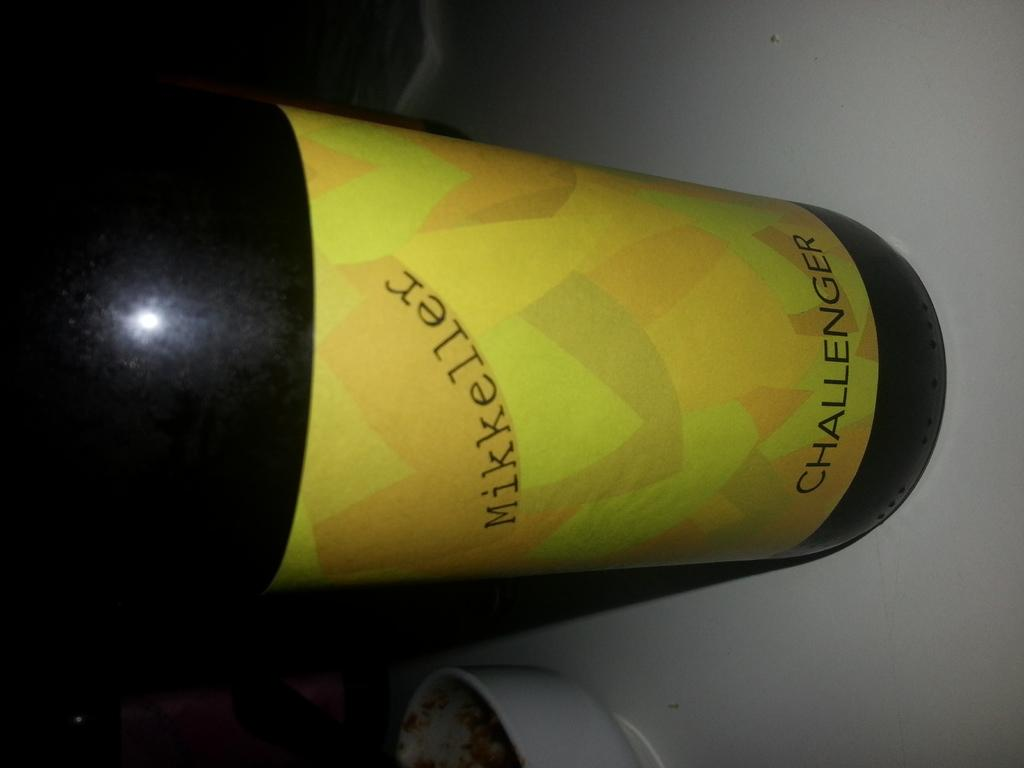<image>
Provide a brief description of the given image. A black bottle that has a yellow Mikkeller Challenger label. 